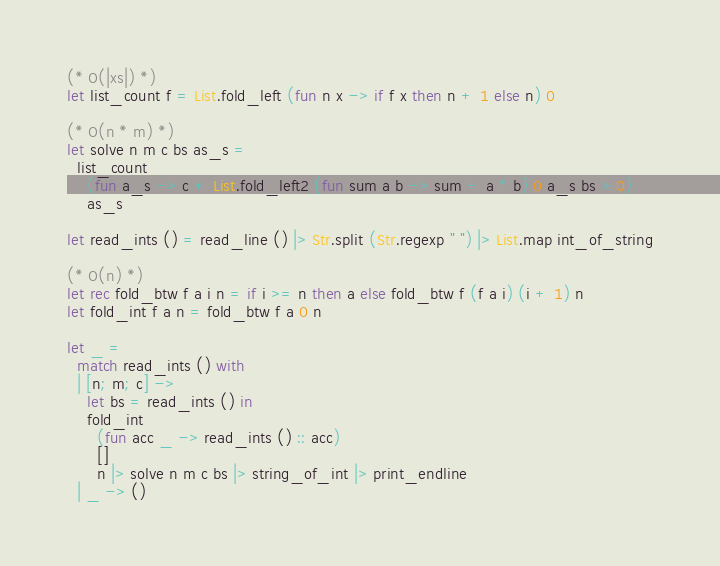Convert code to text. <code><loc_0><loc_0><loc_500><loc_500><_OCaml_>(* O(|xs|) *)
let list_count f = List.fold_left (fun n x -> if f x then n + 1 else n) 0

(* O(n * m) *)
let solve n m c bs as_s =
  list_count
    (fun a_s -> c + List.fold_left2 (fun sum a b -> sum + a * b) 0 a_s bs > 0)
    as_s

let read_ints () = read_line () |> Str.split (Str.regexp " ") |> List.map int_of_string

(* O(n) *)
let rec fold_btw f a i n = if i >= n then a else fold_btw f (f a i) (i + 1) n
let fold_int f a n = fold_btw f a 0 n

let _ =
  match read_ints () with
  | [n; m; c] ->
    let bs = read_ints () in
    fold_int
      (fun acc _ -> read_ints () :: acc)
      []
      n |> solve n m c bs |> string_of_int |> print_endline
  | _ -> ()</code> 